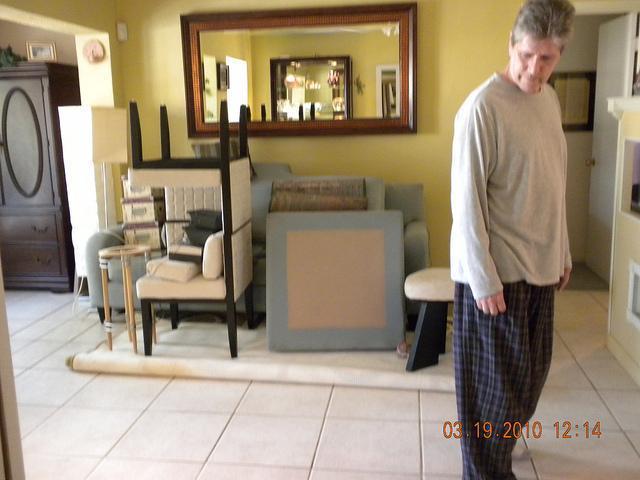How many chairs are there?
Give a very brief answer. 3. 